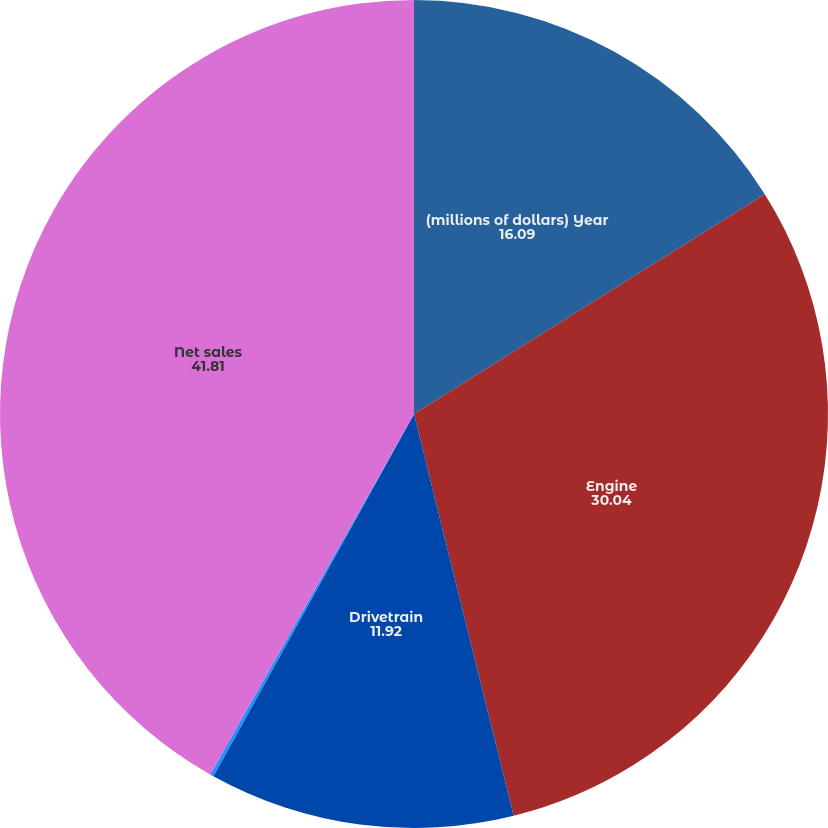Convert chart. <chart><loc_0><loc_0><loc_500><loc_500><pie_chart><fcel>(millions of dollars) Year<fcel>Engine<fcel>Drivetrain<fcel>Inter-segment eliminations<fcel>Net sales<nl><fcel>16.09%<fcel>30.04%<fcel>11.92%<fcel>0.14%<fcel>41.81%<nl></chart> 